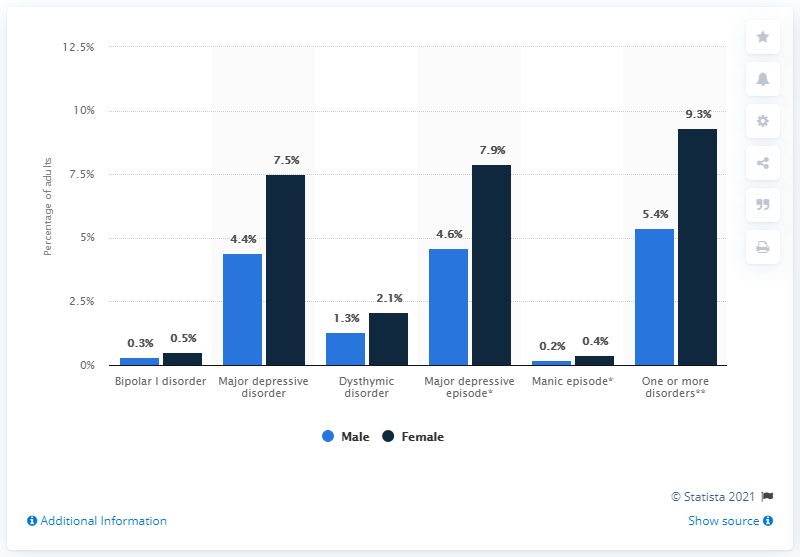Draw attention to some important aspects in this diagram. According to a study, 0.3% of males suffered from bipolar disorder. The disorder with the greatest difference between male and female symptoms over time is unknown. One or more disorders may exhibit this phenomenon. 